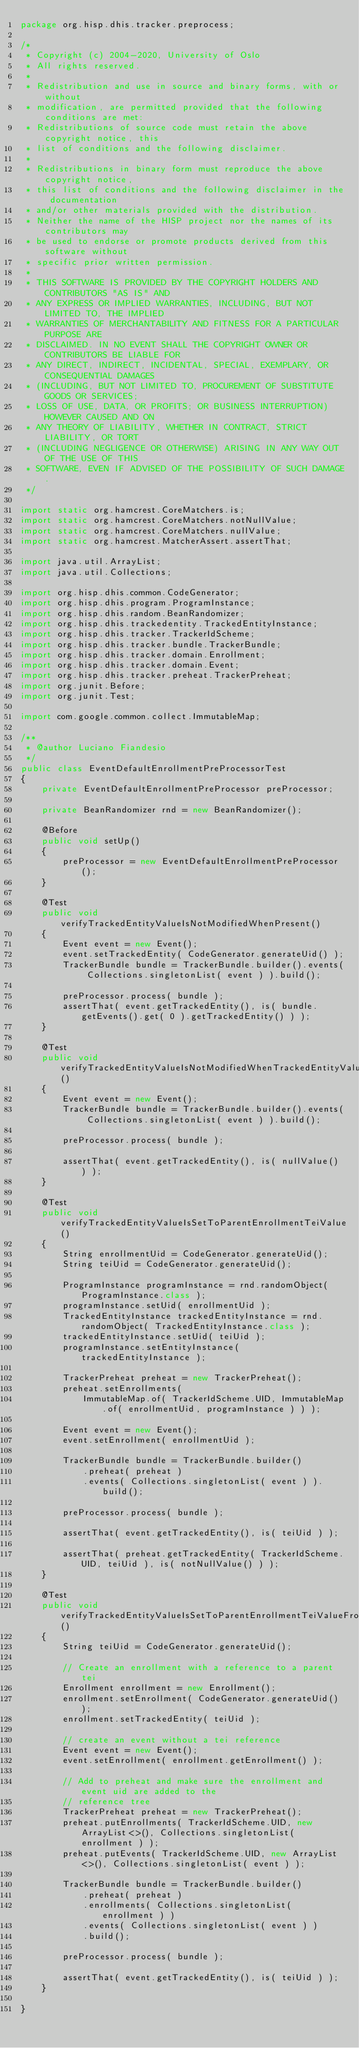Convert code to text. <code><loc_0><loc_0><loc_500><loc_500><_Java_>package org.hisp.dhis.tracker.preprocess;

/*
 * Copyright (c) 2004-2020, University of Oslo
 * All rights reserved.
 *
 * Redistribution and use in source and binary forms, with or without
 * modification, are permitted provided that the following conditions are met:
 * Redistributions of source code must retain the above copyright notice, this
 * list of conditions and the following disclaimer.
 *
 * Redistributions in binary form must reproduce the above copyright notice,
 * this list of conditions and the following disclaimer in the documentation
 * and/or other materials provided with the distribution.
 * Neither the name of the HISP project nor the names of its contributors may
 * be used to endorse or promote products derived from this software without
 * specific prior written permission.
 *
 * THIS SOFTWARE IS PROVIDED BY THE COPYRIGHT HOLDERS AND CONTRIBUTORS "AS IS" AND
 * ANY EXPRESS OR IMPLIED WARRANTIES, INCLUDING, BUT NOT LIMITED TO, THE IMPLIED
 * WARRANTIES OF MERCHANTABILITY AND FITNESS FOR A PARTICULAR PURPOSE ARE
 * DISCLAIMED. IN NO EVENT SHALL THE COPYRIGHT OWNER OR CONTRIBUTORS BE LIABLE FOR
 * ANY DIRECT, INDIRECT, INCIDENTAL, SPECIAL, EXEMPLARY, OR CONSEQUENTIAL DAMAGES
 * (INCLUDING, BUT NOT LIMITED TO, PROCUREMENT OF SUBSTITUTE GOODS OR SERVICES;
 * LOSS OF USE, DATA, OR PROFITS; OR BUSINESS INTERRUPTION) HOWEVER CAUSED AND ON
 * ANY THEORY OF LIABILITY, WHETHER IN CONTRACT, STRICT LIABILITY, OR TORT
 * (INCLUDING NEGLIGENCE OR OTHERWISE) ARISING IN ANY WAY OUT OF THE USE OF THIS
 * SOFTWARE, EVEN IF ADVISED OF THE POSSIBILITY OF SUCH DAMAGE.
 */

import static org.hamcrest.CoreMatchers.is;
import static org.hamcrest.CoreMatchers.notNullValue;
import static org.hamcrest.CoreMatchers.nullValue;
import static org.hamcrest.MatcherAssert.assertThat;

import java.util.ArrayList;
import java.util.Collections;

import org.hisp.dhis.common.CodeGenerator;
import org.hisp.dhis.program.ProgramInstance;
import org.hisp.dhis.random.BeanRandomizer;
import org.hisp.dhis.trackedentity.TrackedEntityInstance;
import org.hisp.dhis.tracker.TrackerIdScheme;
import org.hisp.dhis.tracker.bundle.TrackerBundle;
import org.hisp.dhis.tracker.domain.Enrollment;
import org.hisp.dhis.tracker.domain.Event;
import org.hisp.dhis.tracker.preheat.TrackerPreheat;
import org.junit.Before;
import org.junit.Test;

import com.google.common.collect.ImmutableMap;

/**
 * @author Luciano Fiandesio
 */
public class EventDefaultEnrollmentPreProcessorTest
{
    private EventDefaultEnrollmentPreProcessor preProcessor;

    private BeanRandomizer rnd = new BeanRandomizer();

    @Before
    public void setUp()
    {
        preProcessor = new EventDefaultEnrollmentPreProcessor();
    }

    @Test
    public void verifyTrackedEntityValueIsNotModifiedWhenPresent()
    {
        Event event = new Event();
        event.setTrackedEntity( CodeGenerator.generateUid() );
        TrackerBundle bundle = TrackerBundle.builder().events( Collections.singletonList( event ) ).build();

        preProcessor.process( bundle );
        assertThat( event.getTrackedEntity(), is( bundle.getEvents().get( 0 ).getTrackedEntity() ) );
    }

    @Test
    public void verifyTrackedEntityValueIsNotModifiedWhenTrackedEntityValueAndEnrollmentValueAreMissing()
    {
        Event event = new Event();
        TrackerBundle bundle = TrackerBundle.builder().events( Collections.singletonList( event ) ).build();

        preProcessor.process( bundle );

        assertThat( event.getTrackedEntity(), is( nullValue() ) );
    }

    @Test
    public void verifyTrackedEntityValueIsSetToParentEnrollmentTeiValue()
    {
        String enrollmentUid = CodeGenerator.generateUid();
        String teiUid = CodeGenerator.generateUid();

        ProgramInstance programInstance = rnd.randomObject( ProgramInstance.class );
        programInstance.setUid( enrollmentUid );
        TrackedEntityInstance trackedEntityInstance = rnd.randomObject( TrackedEntityInstance.class );
        trackedEntityInstance.setUid( teiUid );
        programInstance.setEntityInstance( trackedEntityInstance );

        TrackerPreheat preheat = new TrackerPreheat();
        preheat.setEnrollments(
            ImmutableMap.of( TrackerIdScheme.UID, ImmutableMap.of( enrollmentUid, programInstance ) ) );

        Event event = new Event();
        event.setEnrollment( enrollmentUid );

        TrackerBundle bundle = TrackerBundle.builder()
            .preheat( preheat )
            .events( Collections.singletonList( event ) ).build();

        preProcessor.process( bundle );

        assertThat( event.getTrackedEntity(), is( teiUid ) );

        assertThat( preheat.getTrackedEntity( TrackerIdScheme.UID, teiUid ), is( notNullValue() ) );
    }

    @Test
    public void verifyTrackedEntityValueIsSetToParentEnrollmentTeiValueFromRef()
    {
        String teiUid = CodeGenerator.generateUid();

        // Create an enrollment with a reference to a parent tei
        Enrollment enrollment = new Enrollment();
        enrollment.setEnrollment( CodeGenerator.generateUid() );
        enrollment.setTrackedEntity( teiUid );

        // create an event without a tei reference
        Event event = new Event();
        event.setEnrollment( enrollment.getEnrollment() );

        // Add to preheat and make sure the enrollment and event uid are added to the
        // reference tree
        TrackerPreheat preheat = new TrackerPreheat();
        preheat.putEnrollments( TrackerIdScheme.UID, new ArrayList<>(), Collections.singletonList( enrollment ) );
        preheat.putEvents( TrackerIdScheme.UID, new ArrayList<>(), Collections.singletonList( event ) );

        TrackerBundle bundle = TrackerBundle.builder()
            .preheat( preheat )
            .enrollments( Collections.singletonList( enrollment ) )
            .events( Collections.singletonList( event ) )
            .build();

        preProcessor.process( bundle );

        assertThat( event.getTrackedEntity(), is( teiUid ) );
    }

}</code> 